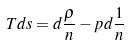Convert formula to latex. <formula><loc_0><loc_0><loc_500><loc_500>T d s = d \frac { \rho } { n } - p d \frac { 1 } { n }</formula> 